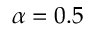<formula> <loc_0><loc_0><loc_500><loc_500>\alpha = 0 . 5</formula> 